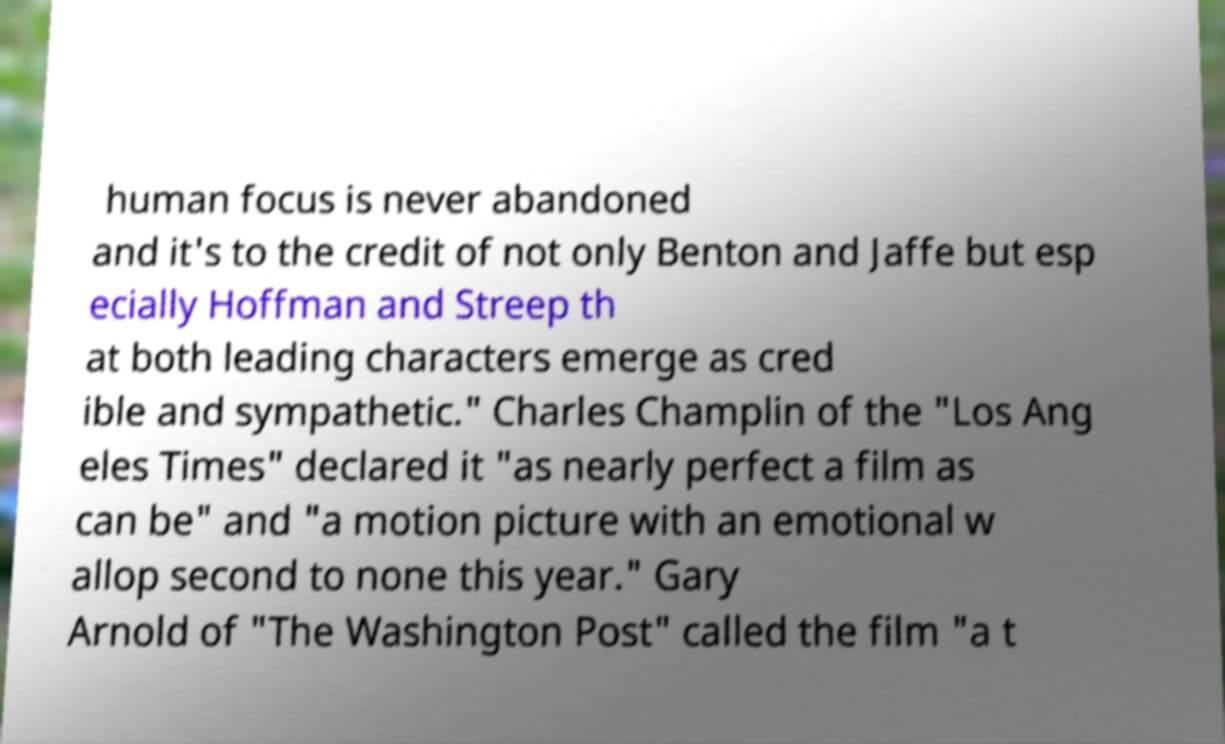Please identify and transcribe the text found in this image. human focus is never abandoned and it's to the credit of not only Benton and Jaffe but esp ecially Hoffman and Streep th at both leading characters emerge as cred ible and sympathetic." Charles Champlin of the "Los Ang eles Times" declared it "as nearly perfect a film as can be" and "a motion picture with an emotional w allop second to none this year." Gary Arnold of "The Washington Post" called the film "a t 